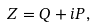<formula> <loc_0><loc_0><loc_500><loc_500>Z = Q + i P ,</formula> 